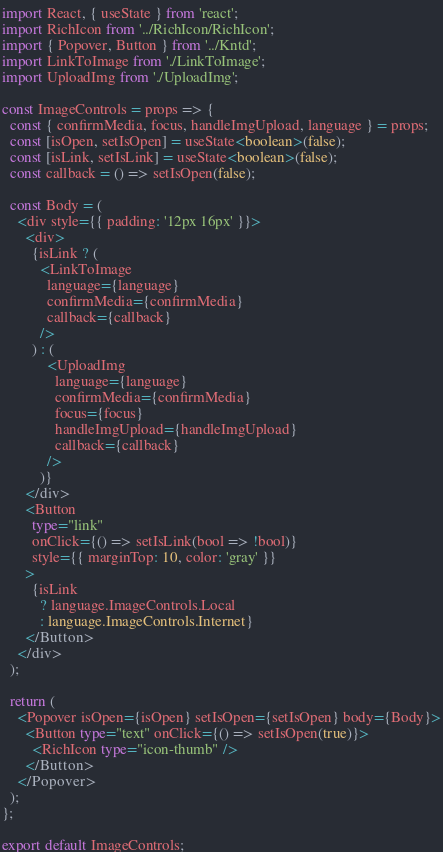Convert code to text. <code><loc_0><loc_0><loc_500><loc_500><_TypeScript_>import React, { useState } from 'react';
import RichIcon from '../RichIcon/RichIcon';
import { Popover, Button } from '../Kntd';
import LinkToImage from './LinkToImage';
import UploadImg from './UploadImg';

const ImageControls = props => {
  const { confirmMedia, focus, handleImgUpload, language } = props;
  const [isOpen, setIsOpen] = useState<boolean>(false);
  const [isLink, setIsLink] = useState<boolean>(false);
  const callback = () => setIsOpen(false);

  const Body = (
    <div style={{ padding: '12px 16px' }}>
      <div>
        {isLink ? (
          <LinkToImage
            language={language}
            confirmMedia={confirmMedia}
            callback={callback}
          />
        ) : (
            <UploadImg
              language={language}
              confirmMedia={confirmMedia}
              focus={focus}
              handleImgUpload={handleImgUpload}
              callback={callback}
            />
          )}
      </div>
      <Button
        type="link"
        onClick={() => setIsLink(bool => !bool)}
        style={{ marginTop: 10, color: 'gray' }}
      >
        {isLink
          ? language.ImageControls.Local
          : language.ImageControls.Internet}
      </Button>
    </div>
  );

  return (
    <Popover isOpen={isOpen} setIsOpen={setIsOpen} body={Body}>
      <Button type="text" onClick={() => setIsOpen(true)}>
        <RichIcon type="icon-thumb" />
      </Button>
    </Popover>
  );
};

export default ImageControls;
</code> 